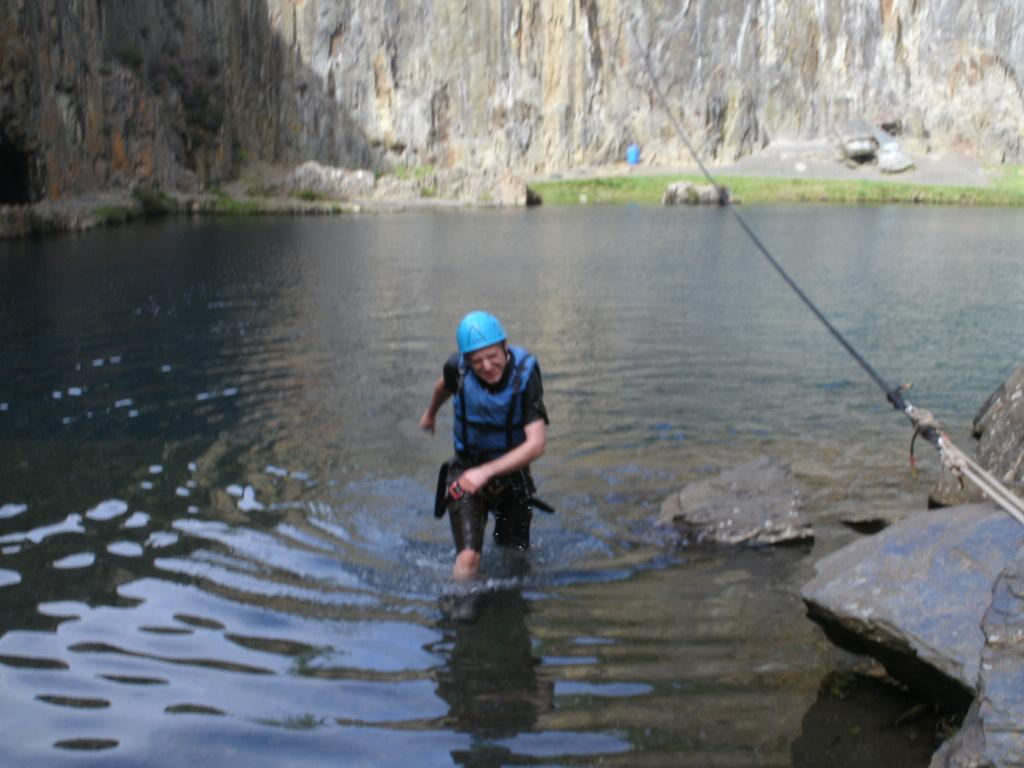What is the person in the image doing? There is a person walking in the water in the image. What can be seen on the right side of the image? There are rocks and a rope on the right side of the image. What is visible in the background of the image? There is a wall in the background of the image. What is the price of the fish in the image? There are no fish present in the image, so it is not possible to determine the price of any fish. 